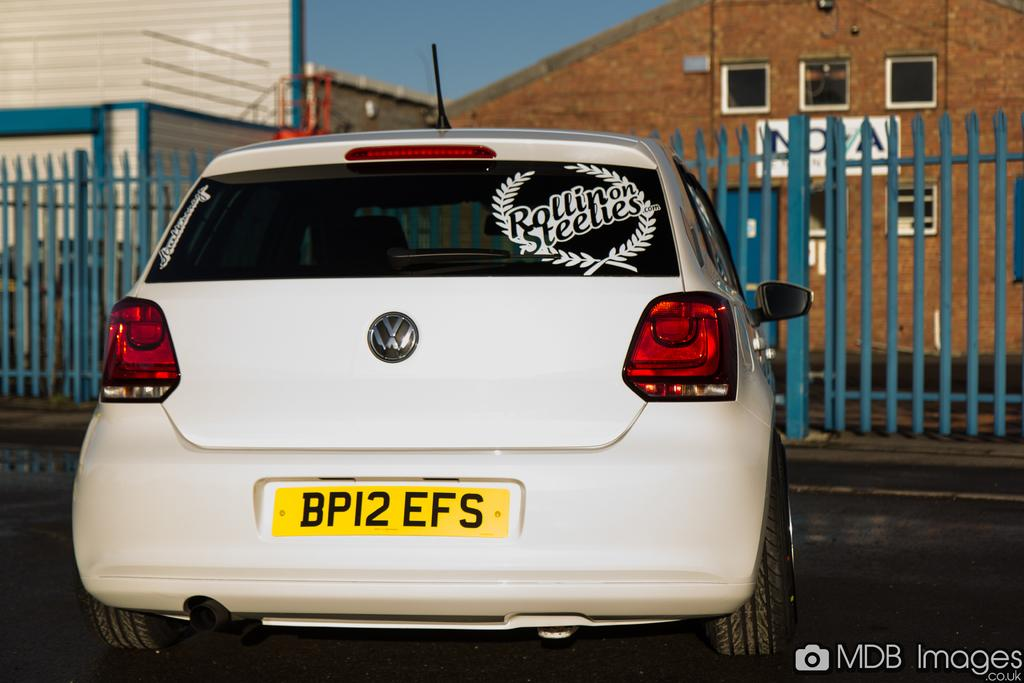<image>
Present a compact description of the photo's key features. Yellow license plate which says BP12EFS for a white car. 